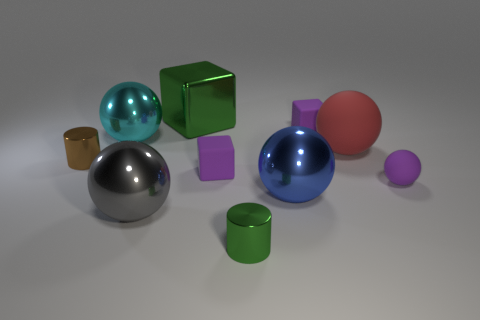Which object in the image appears to be the most reflective, and why might that be? The large blue sphere appears to be the most reflective object due to its shiny surface, which indicates it might be made of a glossy material like polished metal or glass, enhancing its ability to reflect light and surrounding objects. 